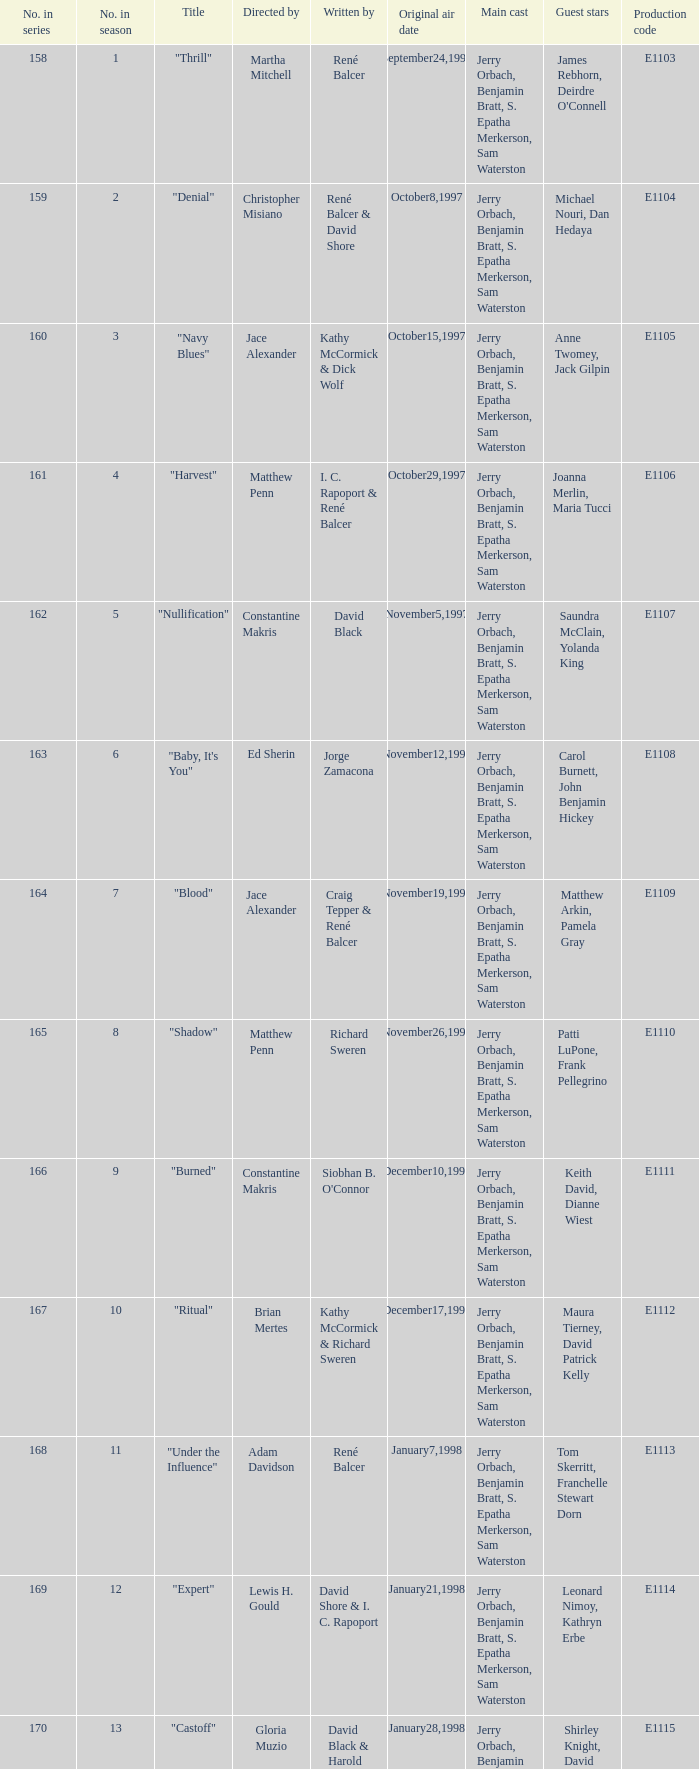Name the title of the episode that ed sherin directed. "Baby, It's You". 